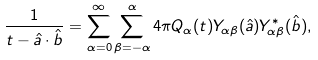<formula> <loc_0><loc_0><loc_500><loc_500>\frac { 1 } { t - \hat { a } \cdot \hat { b } } = \sum _ { \alpha = 0 } ^ { \infty } \sum _ { \beta = - \alpha } ^ { \alpha } 4 \pi Q _ { \alpha } ( t ) Y _ { \alpha \beta } ( \hat { a } ) Y _ { \alpha \beta } ^ { \ast } ( \hat { b } ) ,</formula> 